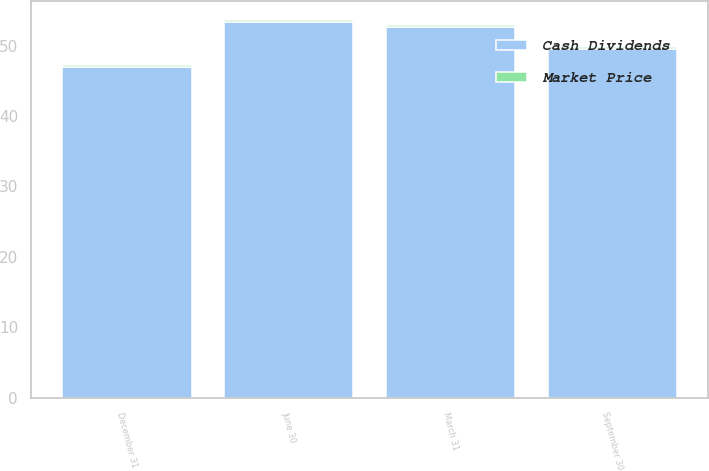<chart> <loc_0><loc_0><loc_500><loc_500><stacked_bar_chart><ecel><fcel>December 31<fcel>September 30<fcel>June 30<fcel>March 31<nl><fcel>Cash Dividends<fcel>47.03<fcel>49.5<fcel>53.31<fcel>52.6<nl><fcel>Market Price<fcel>0.28<fcel>0.28<fcel>0.28<fcel>0.28<nl></chart> 